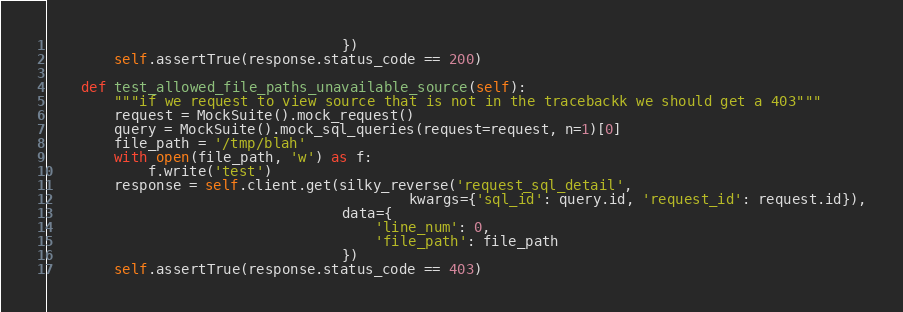<code> <loc_0><loc_0><loc_500><loc_500><_Python_>                                   })
        self.assertTrue(response.status_code == 200)

    def test_allowed_file_paths_unavailable_source(self):
        """if we request to view source that is not in the tracebackk we should get a 403"""
        request = MockSuite().mock_request()
        query = MockSuite().mock_sql_queries(request=request, n=1)[0]
        file_path = '/tmp/blah'
        with open(file_path, 'w') as f:
            f.write('test')
        response = self.client.get(silky_reverse('request_sql_detail',
                                           kwargs={'sql_id': query.id, 'request_id': request.id}),
                                   data={
                                       'line_num': 0,
                                       'file_path': file_path
                                   })
        self.assertTrue(response.status_code == 403)
</code> 